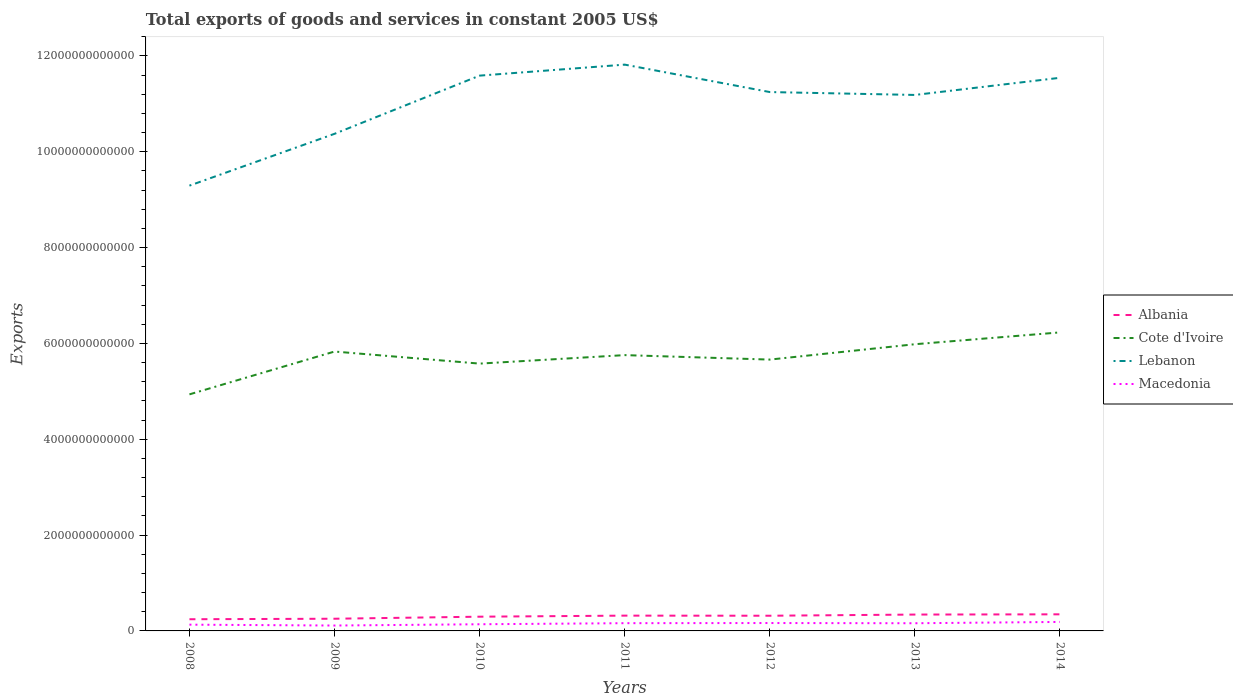Does the line corresponding to Cote d'Ivoire intersect with the line corresponding to Albania?
Offer a very short reply. No. Across all years, what is the maximum total exports of goods and services in Lebanon?
Make the answer very short. 9.29e+12. What is the total total exports of goods and services in Cote d'Ivoire in the graph?
Offer a terse response. 2.52e+11. What is the difference between the highest and the second highest total exports of goods and services in Cote d'Ivoire?
Offer a terse response. 1.29e+12. Is the total exports of goods and services in Albania strictly greater than the total exports of goods and services in Macedonia over the years?
Provide a short and direct response. No. What is the difference between two consecutive major ticks on the Y-axis?
Provide a succinct answer. 2.00e+12. Are the values on the major ticks of Y-axis written in scientific E-notation?
Offer a terse response. No. Does the graph contain any zero values?
Your answer should be compact. No. How many legend labels are there?
Offer a terse response. 4. What is the title of the graph?
Offer a terse response. Total exports of goods and services in constant 2005 US$. Does "Montenegro" appear as one of the legend labels in the graph?
Provide a short and direct response. No. What is the label or title of the X-axis?
Offer a very short reply. Years. What is the label or title of the Y-axis?
Provide a short and direct response. Exports. What is the Exports of Albania in 2008?
Your response must be concise. 2.44e+11. What is the Exports of Cote d'Ivoire in 2008?
Your response must be concise. 4.94e+12. What is the Exports of Lebanon in 2008?
Ensure brevity in your answer.  9.29e+12. What is the Exports of Macedonia in 2008?
Your answer should be very brief. 1.31e+11. What is the Exports in Albania in 2009?
Provide a succinct answer. 2.54e+11. What is the Exports of Cote d'Ivoire in 2009?
Your answer should be compact. 5.83e+12. What is the Exports in Lebanon in 2009?
Provide a short and direct response. 1.04e+13. What is the Exports of Macedonia in 2009?
Your answer should be compact. 1.12e+11. What is the Exports of Albania in 2010?
Make the answer very short. 2.97e+11. What is the Exports in Cote d'Ivoire in 2010?
Your answer should be compact. 5.58e+12. What is the Exports in Lebanon in 2010?
Offer a very short reply. 1.16e+13. What is the Exports in Macedonia in 2010?
Give a very brief answer. 1.39e+11. What is the Exports in Albania in 2011?
Keep it short and to the point. 3.19e+11. What is the Exports of Cote d'Ivoire in 2011?
Keep it short and to the point. 5.76e+12. What is the Exports in Lebanon in 2011?
Ensure brevity in your answer.  1.18e+13. What is the Exports in Macedonia in 2011?
Provide a short and direct response. 1.62e+11. What is the Exports of Albania in 2012?
Offer a terse response. 3.17e+11. What is the Exports of Cote d'Ivoire in 2012?
Your response must be concise. 5.66e+12. What is the Exports in Lebanon in 2012?
Provide a succinct answer. 1.12e+13. What is the Exports of Macedonia in 2012?
Provide a succinct answer. 1.65e+11. What is the Exports in Albania in 2013?
Provide a succinct answer. 3.41e+11. What is the Exports in Cote d'Ivoire in 2013?
Keep it short and to the point. 5.98e+12. What is the Exports of Lebanon in 2013?
Provide a short and direct response. 1.12e+13. What is the Exports in Macedonia in 2013?
Your answer should be very brief. 1.60e+11. What is the Exports in Albania in 2014?
Make the answer very short. 3.46e+11. What is the Exports in Cote d'Ivoire in 2014?
Your answer should be compact. 6.23e+12. What is the Exports of Lebanon in 2014?
Keep it short and to the point. 1.15e+13. What is the Exports of Macedonia in 2014?
Make the answer very short. 1.88e+11. Across all years, what is the maximum Exports in Albania?
Offer a very short reply. 3.46e+11. Across all years, what is the maximum Exports in Cote d'Ivoire?
Your answer should be very brief. 6.23e+12. Across all years, what is the maximum Exports in Lebanon?
Provide a succinct answer. 1.18e+13. Across all years, what is the maximum Exports in Macedonia?
Provide a short and direct response. 1.88e+11. Across all years, what is the minimum Exports in Albania?
Ensure brevity in your answer.  2.44e+11. Across all years, what is the minimum Exports in Cote d'Ivoire?
Your answer should be very brief. 4.94e+12. Across all years, what is the minimum Exports of Lebanon?
Your answer should be compact. 9.29e+12. Across all years, what is the minimum Exports of Macedonia?
Your response must be concise. 1.12e+11. What is the total Exports of Albania in the graph?
Make the answer very short. 2.12e+12. What is the total Exports of Cote d'Ivoire in the graph?
Provide a succinct answer. 4.00e+13. What is the total Exports in Lebanon in the graph?
Offer a terse response. 7.70e+13. What is the total Exports of Macedonia in the graph?
Ensure brevity in your answer.  1.06e+12. What is the difference between the Exports of Albania in 2008 and that in 2009?
Keep it short and to the point. -1.06e+1. What is the difference between the Exports of Cote d'Ivoire in 2008 and that in 2009?
Offer a terse response. -8.94e+11. What is the difference between the Exports of Lebanon in 2008 and that in 2009?
Your answer should be very brief. -1.08e+12. What is the difference between the Exports in Macedonia in 2008 and that in 2009?
Offer a terse response. 1.81e+1. What is the difference between the Exports of Albania in 2008 and that in 2010?
Your response must be concise. -5.33e+1. What is the difference between the Exports in Cote d'Ivoire in 2008 and that in 2010?
Offer a very short reply. -6.42e+11. What is the difference between the Exports in Lebanon in 2008 and that in 2010?
Offer a terse response. -2.30e+12. What is the difference between the Exports of Macedonia in 2008 and that in 2010?
Your response must be concise. -8.49e+09. What is the difference between the Exports in Albania in 2008 and that in 2011?
Offer a very short reply. -7.53e+1. What is the difference between the Exports of Cote d'Ivoire in 2008 and that in 2011?
Offer a very short reply. -8.19e+11. What is the difference between the Exports in Lebanon in 2008 and that in 2011?
Your answer should be very brief. -2.53e+12. What is the difference between the Exports of Macedonia in 2008 and that in 2011?
Ensure brevity in your answer.  -3.09e+1. What is the difference between the Exports of Albania in 2008 and that in 2012?
Provide a succinct answer. -7.32e+1. What is the difference between the Exports of Cote d'Ivoire in 2008 and that in 2012?
Keep it short and to the point. -7.26e+11. What is the difference between the Exports in Lebanon in 2008 and that in 2012?
Your answer should be compact. -1.95e+12. What is the difference between the Exports in Macedonia in 2008 and that in 2012?
Your response must be concise. -3.41e+1. What is the difference between the Exports in Albania in 2008 and that in 2013?
Your response must be concise. -9.76e+1. What is the difference between the Exports in Cote d'Ivoire in 2008 and that in 2013?
Offer a terse response. -1.05e+12. What is the difference between the Exports of Lebanon in 2008 and that in 2013?
Your answer should be very brief. -1.89e+12. What is the difference between the Exports in Macedonia in 2008 and that in 2013?
Give a very brief answer. -2.97e+1. What is the difference between the Exports of Albania in 2008 and that in 2014?
Provide a short and direct response. -1.03e+11. What is the difference between the Exports in Cote d'Ivoire in 2008 and that in 2014?
Offer a very short reply. -1.29e+12. What is the difference between the Exports of Lebanon in 2008 and that in 2014?
Your answer should be very brief. -2.25e+12. What is the difference between the Exports of Macedonia in 2008 and that in 2014?
Your answer should be very brief. -5.70e+1. What is the difference between the Exports in Albania in 2009 and that in 2010?
Offer a terse response. -4.27e+1. What is the difference between the Exports of Cote d'Ivoire in 2009 and that in 2010?
Your response must be concise. 2.52e+11. What is the difference between the Exports of Lebanon in 2009 and that in 2010?
Your answer should be compact. -1.21e+12. What is the difference between the Exports in Macedonia in 2009 and that in 2010?
Make the answer very short. -2.66e+1. What is the difference between the Exports of Albania in 2009 and that in 2011?
Your answer should be compact. -6.47e+1. What is the difference between the Exports in Cote d'Ivoire in 2009 and that in 2011?
Keep it short and to the point. 7.47e+1. What is the difference between the Exports of Lebanon in 2009 and that in 2011?
Your answer should be very brief. -1.44e+12. What is the difference between the Exports of Macedonia in 2009 and that in 2011?
Offer a terse response. -4.91e+1. What is the difference between the Exports of Albania in 2009 and that in 2012?
Give a very brief answer. -6.26e+1. What is the difference between the Exports in Cote d'Ivoire in 2009 and that in 2012?
Your answer should be very brief. 1.68e+11. What is the difference between the Exports in Lebanon in 2009 and that in 2012?
Keep it short and to the point. -8.71e+11. What is the difference between the Exports in Macedonia in 2009 and that in 2012?
Provide a short and direct response. -5.22e+1. What is the difference between the Exports in Albania in 2009 and that in 2013?
Make the answer very short. -8.70e+1. What is the difference between the Exports in Cote d'Ivoire in 2009 and that in 2013?
Give a very brief answer. -1.53e+11. What is the difference between the Exports of Lebanon in 2009 and that in 2013?
Offer a very short reply. -8.11e+11. What is the difference between the Exports in Macedonia in 2009 and that in 2013?
Your response must be concise. -4.78e+1. What is the difference between the Exports of Albania in 2009 and that in 2014?
Provide a short and direct response. -9.19e+1. What is the difference between the Exports in Cote d'Ivoire in 2009 and that in 2014?
Make the answer very short. -3.99e+11. What is the difference between the Exports in Lebanon in 2009 and that in 2014?
Your response must be concise. -1.17e+12. What is the difference between the Exports of Macedonia in 2009 and that in 2014?
Your answer should be compact. -7.51e+1. What is the difference between the Exports of Albania in 2010 and that in 2011?
Provide a short and direct response. -2.20e+1. What is the difference between the Exports of Cote d'Ivoire in 2010 and that in 2011?
Ensure brevity in your answer.  -1.77e+11. What is the difference between the Exports of Lebanon in 2010 and that in 2011?
Your answer should be compact. -2.30e+11. What is the difference between the Exports of Macedonia in 2010 and that in 2011?
Make the answer very short. -2.24e+1. What is the difference between the Exports in Albania in 2010 and that in 2012?
Ensure brevity in your answer.  -2.00e+1. What is the difference between the Exports in Cote d'Ivoire in 2010 and that in 2012?
Your answer should be compact. -8.40e+1. What is the difference between the Exports in Lebanon in 2010 and that in 2012?
Your answer should be very brief. 3.43e+11. What is the difference between the Exports in Macedonia in 2010 and that in 2012?
Your answer should be compact. -2.56e+1. What is the difference between the Exports of Albania in 2010 and that in 2013?
Your answer should be very brief. -4.44e+1. What is the difference between the Exports of Cote d'Ivoire in 2010 and that in 2013?
Provide a short and direct response. -4.04e+11. What is the difference between the Exports in Lebanon in 2010 and that in 2013?
Provide a short and direct response. 4.03e+11. What is the difference between the Exports in Macedonia in 2010 and that in 2013?
Keep it short and to the point. -2.12e+1. What is the difference between the Exports of Albania in 2010 and that in 2014?
Provide a succinct answer. -4.92e+1. What is the difference between the Exports in Cote d'Ivoire in 2010 and that in 2014?
Make the answer very short. -6.51e+11. What is the difference between the Exports of Lebanon in 2010 and that in 2014?
Provide a succinct answer. 4.51e+1. What is the difference between the Exports of Macedonia in 2010 and that in 2014?
Your answer should be very brief. -4.85e+1. What is the difference between the Exports in Albania in 2011 and that in 2012?
Offer a terse response. 2.04e+09. What is the difference between the Exports of Cote d'Ivoire in 2011 and that in 2012?
Your response must be concise. 9.32e+1. What is the difference between the Exports of Lebanon in 2011 and that in 2012?
Give a very brief answer. 5.72e+11. What is the difference between the Exports of Macedonia in 2011 and that in 2012?
Offer a very short reply. -3.15e+09. What is the difference between the Exports in Albania in 2011 and that in 2013?
Offer a terse response. -2.24e+1. What is the difference between the Exports in Cote d'Ivoire in 2011 and that in 2013?
Make the answer very short. -2.27e+11. What is the difference between the Exports of Lebanon in 2011 and that in 2013?
Offer a terse response. 6.33e+11. What is the difference between the Exports of Macedonia in 2011 and that in 2013?
Your response must be concise. 1.27e+09. What is the difference between the Exports of Albania in 2011 and that in 2014?
Keep it short and to the point. -2.72e+1. What is the difference between the Exports of Cote d'Ivoire in 2011 and that in 2014?
Keep it short and to the point. -4.74e+11. What is the difference between the Exports in Lebanon in 2011 and that in 2014?
Give a very brief answer. 2.75e+11. What is the difference between the Exports of Macedonia in 2011 and that in 2014?
Give a very brief answer. -2.60e+1. What is the difference between the Exports in Albania in 2012 and that in 2013?
Your response must be concise. -2.44e+1. What is the difference between the Exports of Cote d'Ivoire in 2012 and that in 2013?
Make the answer very short. -3.20e+11. What is the difference between the Exports of Lebanon in 2012 and that in 2013?
Make the answer very short. 6.03e+1. What is the difference between the Exports of Macedonia in 2012 and that in 2013?
Provide a short and direct response. 4.42e+09. What is the difference between the Exports of Albania in 2012 and that in 2014?
Offer a terse response. -2.93e+1. What is the difference between the Exports in Cote d'Ivoire in 2012 and that in 2014?
Your response must be concise. -5.67e+11. What is the difference between the Exports in Lebanon in 2012 and that in 2014?
Keep it short and to the point. -2.98e+11. What is the difference between the Exports of Macedonia in 2012 and that in 2014?
Provide a succinct answer. -2.29e+1. What is the difference between the Exports in Albania in 2013 and that in 2014?
Your answer should be very brief. -4.86e+09. What is the difference between the Exports of Cote d'Ivoire in 2013 and that in 2014?
Provide a succinct answer. -2.47e+11. What is the difference between the Exports of Lebanon in 2013 and that in 2014?
Provide a succinct answer. -3.58e+11. What is the difference between the Exports of Macedonia in 2013 and that in 2014?
Your response must be concise. -2.73e+1. What is the difference between the Exports in Albania in 2008 and the Exports in Cote d'Ivoire in 2009?
Provide a short and direct response. -5.59e+12. What is the difference between the Exports of Albania in 2008 and the Exports of Lebanon in 2009?
Provide a succinct answer. -1.01e+13. What is the difference between the Exports of Albania in 2008 and the Exports of Macedonia in 2009?
Provide a succinct answer. 1.31e+11. What is the difference between the Exports in Cote d'Ivoire in 2008 and the Exports in Lebanon in 2009?
Keep it short and to the point. -5.44e+12. What is the difference between the Exports of Cote d'Ivoire in 2008 and the Exports of Macedonia in 2009?
Your answer should be very brief. 4.82e+12. What is the difference between the Exports of Lebanon in 2008 and the Exports of Macedonia in 2009?
Make the answer very short. 9.18e+12. What is the difference between the Exports of Albania in 2008 and the Exports of Cote d'Ivoire in 2010?
Offer a very short reply. -5.33e+12. What is the difference between the Exports of Albania in 2008 and the Exports of Lebanon in 2010?
Give a very brief answer. -1.13e+13. What is the difference between the Exports in Albania in 2008 and the Exports in Macedonia in 2010?
Offer a terse response. 1.05e+11. What is the difference between the Exports in Cote d'Ivoire in 2008 and the Exports in Lebanon in 2010?
Offer a very short reply. -6.65e+12. What is the difference between the Exports in Cote d'Ivoire in 2008 and the Exports in Macedonia in 2010?
Keep it short and to the point. 4.80e+12. What is the difference between the Exports in Lebanon in 2008 and the Exports in Macedonia in 2010?
Ensure brevity in your answer.  9.15e+12. What is the difference between the Exports of Albania in 2008 and the Exports of Cote d'Ivoire in 2011?
Provide a short and direct response. -5.51e+12. What is the difference between the Exports in Albania in 2008 and the Exports in Lebanon in 2011?
Your answer should be compact. -1.16e+13. What is the difference between the Exports of Albania in 2008 and the Exports of Macedonia in 2011?
Provide a short and direct response. 8.23e+1. What is the difference between the Exports in Cote d'Ivoire in 2008 and the Exports in Lebanon in 2011?
Make the answer very short. -6.88e+12. What is the difference between the Exports in Cote d'Ivoire in 2008 and the Exports in Macedonia in 2011?
Keep it short and to the point. 4.77e+12. What is the difference between the Exports in Lebanon in 2008 and the Exports in Macedonia in 2011?
Make the answer very short. 9.13e+12. What is the difference between the Exports of Albania in 2008 and the Exports of Cote d'Ivoire in 2012?
Your answer should be compact. -5.42e+12. What is the difference between the Exports in Albania in 2008 and the Exports in Lebanon in 2012?
Provide a short and direct response. -1.10e+13. What is the difference between the Exports of Albania in 2008 and the Exports of Macedonia in 2012?
Your answer should be compact. 7.91e+1. What is the difference between the Exports in Cote d'Ivoire in 2008 and the Exports in Lebanon in 2012?
Offer a very short reply. -6.31e+12. What is the difference between the Exports in Cote d'Ivoire in 2008 and the Exports in Macedonia in 2012?
Make the answer very short. 4.77e+12. What is the difference between the Exports in Lebanon in 2008 and the Exports in Macedonia in 2012?
Offer a terse response. 9.13e+12. What is the difference between the Exports of Albania in 2008 and the Exports of Cote d'Ivoire in 2013?
Your answer should be very brief. -5.74e+12. What is the difference between the Exports of Albania in 2008 and the Exports of Lebanon in 2013?
Your answer should be compact. -1.09e+13. What is the difference between the Exports of Albania in 2008 and the Exports of Macedonia in 2013?
Offer a very short reply. 8.35e+1. What is the difference between the Exports of Cote d'Ivoire in 2008 and the Exports of Lebanon in 2013?
Ensure brevity in your answer.  -6.25e+12. What is the difference between the Exports of Cote d'Ivoire in 2008 and the Exports of Macedonia in 2013?
Offer a very short reply. 4.78e+12. What is the difference between the Exports in Lebanon in 2008 and the Exports in Macedonia in 2013?
Give a very brief answer. 9.13e+12. What is the difference between the Exports in Albania in 2008 and the Exports in Cote d'Ivoire in 2014?
Offer a terse response. -5.99e+12. What is the difference between the Exports of Albania in 2008 and the Exports of Lebanon in 2014?
Your answer should be very brief. -1.13e+13. What is the difference between the Exports in Albania in 2008 and the Exports in Macedonia in 2014?
Your answer should be compact. 5.62e+1. What is the difference between the Exports of Cote d'Ivoire in 2008 and the Exports of Lebanon in 2014?
Give a very brief answer. -6.61e+12. What is the difference between the Exports in Cote d'Ivoire in 2008 and the Exports in Macedonia in 2014?
Your answer should be very brief. 4.75e+12. What is the difference between the Exports in Lebanon in 2008 and the Exports in Macedonia in 2014?
Ensure brevity in your answer.  9.10e+12. What is the difference between the Exports in Albania in 2009 and the Exports in Cote d'Ivoire in 2010?
Your answer should be compact. -5.32e+12. What is the difference between the Exports in Albania in 2009 and the Exports in Lebanon in 2010?
Give a very brief answer. -1.13e+13. What is the difference between the Exports of Albania in 2009 and the Exports of Macedonia in 2010?
Keep it short and to the point. 1.15e+11. What is the difference between the Exports in Cote d'Ivoire in 2009 and the Exports in Lebanon in 2010?
Keep it short and to the point. -5.76e+12. What is the difference between the Exports of Cote d'Ivoire in 2009 and the Exports of Macedonia in 2010?
Offer a very short reply. 5.69e+12. What is the difference between the Exports in Lebanon in 2009 and the Exports in Macedonia in 2010?
Provide a succinct answer. 1.02e+13. What is the difference between the Exports of Albania in 2009 and the Exports of Cote d'Ivoire in 2011?
Make the answer very short. -5.50e+12. What is the difference between the Exports of Albania in 2009 and the Exports of Lebanon in 2011?
Your answer should be compact. -1.16e+13. What is the difference between the Exports of Albania in 2009 and the Exports of Macedonia in 2011?
Offer a very short reply. 9.29e+1. What is the difference between the Exports in Cote d'Ivoire in 2009 and the Exports in Lebanon in 2011?
Your response must be concise. -5.99e+12. What is the difference between the Exports of Cote d'Ivoire in 2009 and the Exports of Macedonia in 2011?
Keep it short and to the point. 5.67e+12. What is the difference between the Exports in Lebanon in 2009 and the Exports in Macedonia in 2011?
Offer a terse response. 1.02e+13. What is the difference between the Exports in Albania in 2009 and the Exports in Cote d'Ivoire in 2012?
Give a very brief answer. -5.41e+12. What is the difference between the Exports of Albania in 2009 and the Exports of Lebanon in 2012?
Give a very brief answer. -1.10e+13. What is the difference between the Exports of Albania in 2009 and the Exports of Macedonia in 2012?
Provide a succinct answer. 8.97e+1. What is the difference between the Exports of Cote d'Ivoire in 2009 and the Exports of Lebanon in 2012?
Ensure brevity in your answer.  -5.41e+12. What is the difference between the Exports of Cote d'Ivoire in 2009 and the Exports of Macedonia in 2012?
Your response must be concise. 5.67e+12. What is the difference between the Exports of Lebanon in 2009 and the Exports of Macedonia in 2012?
Give a very brief answer. 1.02e+13. What is the difference between the Exports in Albania in 2009 and the Exports in Cote d'Ivoire in 2013?
Your answer should be very brief. -5.73e+12. What is the difference between the Exports of Albania in 2009 and the Exports of Lebanon in 2013?
Ensure brevity in your answer.  -1.09e+13. What is the difference between the Exports of Albania in 2009 and the Exports of Macedonia in 2013?
Make the answer very short. 9.41e+1. What is the difference between the Exports in Cote d'Ivoire in 2009 and the Exports in Lebanon in 2013?
Your answer should be very brief. -5.35e+12. What is the difference between the Exports of Cote d'Ivoire in 2009 and the Exports of Macedonia in 2013?
Your response must be concise. 5.67e+12. What is the difference between the Exports of Lebanon in 2009 and the Exports of Macedonia in 2013?
Keep it short and to the point. 1.02e+13. What is the difference between the Exports in Albania in 2009 and the Exports in Cote d'Ivoire in 2014?
Give a very brief answer. -5.97e+12. What is the difference between the Exports in Albania in 2009 and the Exports in Lebanon in 2014?
Ensure brevity in your answer.  -1.13e+13. What is the difference between the Exports of Albania in 2009 and the Exports of Macedonia in 2014?
Give a very brief answer. 6.68e+1. What is the difference between the Exports of Cote d'Ivoire in 2009 and the Exports of Lebanon in 2014?
Make the answer very short. -5.71e+12. What is the difference between the Exports in Cote d'Ivoire in 2009 and the Exports in Macedonia in 2014?
Ensure brevity in your answer.  5.64e+12. What is the difference between the Exports in Lebanon in 2009 and the Exports in Macedonia in 2014?
Offer a terse response. 1.02e+13. What is the difference between the Exports in Albania in 2010 and the Exports in Cote d'Ivoire in 2011?
Your answer should be compact. -5.46e+12. What is the difference between the Exports in Albania in 2010 and the Exports in Lebanon in 2011?
Provide a short and direct response. -1.15e+13. What is the difference between the Exports of Albania in 2010 and the Exports of Macedonia in 2011?
Your answer should be very brief. 1.36e+11. What is the difference between the Exports of Cote d'Ivoire in 2010 and the Exports of Lebanon in 2011?
Offer a terse response. -6.24e+12. What is the difference between the Exports in Cote d'Ivoire in 2010 and the Exports in Macedonia in 2011?
Keep it short and to the point. 5.42e+12. What is the difference between the Exports in Lebanon in 2010 and the Exports in Macedonia in 2011?
Keep it short and to the point. 1.14e+13. What is the difference between the Exports of Albania in 2010 and the Exports of Cote d'Ivoire in 2012?
Keep it short and to the point. -5.36e+12. What is the difference between the Exports of Albania in 2010 and the Exports of Lebanon in 2012?
Provide a succinct answer. -1.09e+13. What is the difference between the Exports in Albania in 2010 and the Exports in Macedonia in 2012?
Offer a very short reply. 1.32e+11. What is the difference between the Exports in Cote d'Ivoire in 2010 and the Exports in Lebanon in 2012?
Keep it short and to the point. -5.67e+12. What is the difference between the Exports in Cote d'Ivoire in 2010 and the Exports in Macedonia in 2012?
Provide a short and direct response. 5.41e+12. What is the difference between the Exports in Lebanon in 2010 and the Exports in Macedonia in 2012?
Make the answer very short. 1.14e+13. What is the difference between the Exports in Albania in 2010 and the Exports in Cote d'Ivoire in 2013?
Make the answer very short. -5.69e+12. What is the difference between the Exports in Albania in 2010 and the Exports in Lebanon in 2013?
Keep it short and to the point. -1.09e+13. What is the difference between the Exports in Albania in 2010 and the Exports in Macedonia in 2013?
Your answer should be very brief. 1.37e+11. What is the difference between the Exports in Cote d'Ivoire in 2010 and the Exports in Lebanon in 2013?
Give a very brief answer. -5.61e+12. What is the difference between the Exports of Cote d'Ivoire in 2010 and the Exports of Macedonia in 2013?
Your response must be concise. 5.42e+12. What is the difference between the Exports in Lebanon in 2010 and the Exports in Macedonia in 2013?
Provide a short and direct response. 1.14e+13. What is the difference between the Exports in Albania in 2010 and the Exports in Cote d'Ivoire in 2014?
Provide a short and direct response. -5.93e+12. What is the difference between the Exports in Albania in 2010 and the Exports in Lebanon in 2014?
Ensure brevity in your answer.  -1.12e+13. What is the difference between the Exports of Albania in 2010 and the Exports of Macedonia in 2014?
Provide a short and direct response. 1.09e+11. What is the difference between the Exports of Cote d'Ivoire in 2010 and the Exports of Lebanon in 2014?
Ensure brevity in your answer.  -5.96e+12. What is the difference between the Exports in Cote d'Ivoire in 2010 and the Exports in Macedonia in 2014?
Offer a very short reply. 5.39e+12. What is the difference between the Exports in Lebanon in 2010 and the Exports in Macedonia in 2014?
Your answer should be very brief. 1.14e+13. What is the difference between the Exports of Albania in 2011 and the Exports of Cote d'Ivoire in 2012?
Give a very brief answer. -5.34e+12. What is the difference between the Exports of Albania in 2011 and the Exports of Lebanon in 2012?
Keep it short and to the point. -1.09e+13. What is the difference between the Exports in Albania in 2011 and the Exports in Macedonia in 2012?
Offer a terse response. 1.54e+11. What is the difference between the Exports in Cote d'Ivoire in 2011 and the Exports in Lebanon in 2012?
Offer a terse response. -5.49e+12. What is the difference between the Exports in Cote d'Ivoire in 2011 and the Exports in Macedonia in 2012?
Your response must be concise. 5.59e+12. What is the difference between the Exports in Lebanon in 2011 and the Exports in Macedonia in 2012?
Offer a terse response. 1.17e+13. What is the difference between the Exports of Albania in 2011 and the Exports of Cote d'Ivoire in 2013?
Your answer should be very brief. -5.66e+12. What is the difference between the Exports of Albania in 2011 and the Exports of Lebanon in 2013?
Keep it short and to the point. -1.09e+13. What is the difference between the Exports of Albania in 2011 and the Exports of Macedonia in 2013?
Offer a terse response. 1.59e+11. What is the difference between the Exports in Cote d'Ivoire in 2011 and the Exports in Lebanon in 2013?
Offer a terse response. -5.43e+12. What is the difference between the Exports of Cote d'Ivoire in 2011 and the Exports of Macedonia in 2013?
Provide a short and direct response. 5.59e+12. What is the difference between the Exports of Lebanon in 2011 and the Exports of Macedonia in 2013?
Give a very brief answer. 1.17e+13. What is the difference between the Exports of Albania in 2011 and the Exports of Cote d'Ivoire in 2014?
Make the answer very short. -5.91e+12. What is the difference between the Exports of Albania in 2011 and the Exports of Lebanon in 2014?
Give a very brief answer. -1.12e+13. What is the difference between the Exports in Albania in 2011 and the Exports in Macedonia in 2014?
Provide a succinct answer. 1.31e+11. What is the difference between the Exports in Cote d'Ivoire in 2011 and the Exports in Lebanon in 2014?
Offer a terse response. -5.79e+12. What is the difference between the Exports in Cote d'Ivoire in 2011 and the Exports in Macedonia in 2014?
Keep it short and to the point. 5.57e+12. What is the difference between the Exports of Lebanon in 2011 and the Exports of Macedonia in 2014?
Keep it short and to the point. 1.16e+13. What is the difference between the Exports in Albania in 2012 and the Exports in Cote d'Ivoire in 2013?
Your response must be concise. -5.67e+12. What is the difference between the Exports of Albania in 2012 and the Exports of Lebanon in 2013?
Provide a short and direct response. -1.09e+13. What is the difference between the Exports of Albania in 2012 and the Exports of Macedonia in 2013?
Your answer should be compact. 1.57e+11. What is the difference between the Exports of Cote d'Ivoire in 2012 and the Exports of Lebanon in 2013?
Give a very brief answer. -5.52e+12. What is the difference between the Exports in Cote d'Ivoire in 2012 and the Exports in Macedonia in 2013?
Give a very brief answer. 5.50e+12. What is the difference between the Exports of Lebanon in 2012 and the Exports of Macedonia in 2013?
Ensure brevity in your answer.  1.11e+13. What is the difference between the Exports of Albania in 2012 and the Exports of Cote d'Ivoire in 2014?
Keep it short and to the point. -5.91e+12. What is the difference between the Exports of Albania in 2012 and the Exports of Lebanon in 2014?
Your answer should be very brief. -1.12e+13. What is the difference between the Exports in Albania in 2012 and the Exports in Macedonia in 2014?
Offer a terse response. 1.29e+11. What is the difference between the Exports in Cote d'Ivoire in 2012 and the Exports in Lebanon in 2014?
Make the answer very short. -5.88e+12. What is the difference between the Exports in Cote d'Ivoire in 2012 and the Exports in Macedonia in 2014?
Your response must be concise. 5.47e+12. What is the difference between the Exports of Lebanon in 2012 and the Exports of Macedonia in 2014?
Your answer should be compact. 1.11e+13. What is the difference between the Exports in Albania in 2013 and the Exports in Cote d'Ivoire in 2014?
Provide a succinct answer. -5.89e+12. What is the difference between the Exports of Albania in 2013 and the Exports of Lebanon in 2014?
Your response must be concise. -1.12e+13. What is the difference between the Exports of Albania in 2013 and the Exports of Macedonia in 2014?
Offer a very short reply. 1.54e+11. What is the difference between the Exports of Cote d'Ivoire in 2013 and the Exports of Lebanon in 2014?
Provide a short and direct response. -5.56e+12. What is the difference between the Exports in Cote d'Ivoire in 2013 and the Exports in Macedonia in 2014?
Your response must be concise. 5.79e+12. What is the difference between the Exports of Lebanon in 2013 and the Exports of Macedonia in 2014?
Offer a very short reply. 1.10e+13. What is the average Exports of Albania per year?
Ensure brevity in your answer.  3.03e+11. What is the average Exports of Cote d'Ivoire per year?
Make the answer very short. 5.71e+12. What is the average Exports of Lebanon per year?
Ensure brevity in your answer.  1.10e+13. What is the average Exports of Macedonia per year?
Provide a short and direct response. 1.51e+11. In the year 2008, what is the difference between the Exports in Albania and Exports in Cote d'Ivoire?
Offer a very short reply. -4.69e+12. In the year 2008, what is the difference between the Exports of Albania and Exports of Lebanon?
Provide a succinct answer. -9.05e+12. In the year 2008, what is the difference between the Exports of Albania and Exports of Macedonia?
Give a very brief answer. 1.13e+11. In the year 2008, what is the difference between the Exports in Cote d'Ivoire and Exports in Lebanon?
Offer a very short reply. -4.36e+12. In the year 2008, what is the difference between the Exports in Cote d'Ivoire and Exports in Macedonia?
Provide a succinct answer. 4.81e+12. In the year 2008, what is the difference between the Exports in Lebanon and Exports in Macedonia?
Your response must be concise. 9.16e+12. In the year 2009, what is the difference between the Exports in Albania and Exports in Cote d'Ivoire?
Your answer should be very brief. -5.58e+12. In the year 2009, what is the difference between the Exports in Albania and Exports in Lebanon?
Your answer should be compact. -1.01e+13. In the year 2009, what is the difference between the Exports of Albania and Exports of Macedonia?
Provide a short and direct response. 1.42e+11. In the year 2009, what is the difference between the Exports in Cote d'Ivoire and Exports in Lebanon?
Give a very brief answer. -4.54e+12. In the year 2009, what is the difference between the Exports in Cote d'Ivoire and Exports in Macedonia?
Keep it short and to the point. 5.72e+12. In the year 2009, what is the difference between the Exports in Lebanon and Exports in Macedonia?
Ensure brevity in your answer.  1.03e+13. In the year 2010, what is the difference between the Exports in Albania and Exports in Cote d'Ivoire?
Offer a terse response. -5.28e+12. In the year 2010, what is the difference between the Exports in Albania and Exports in Lebanon?
Provide a short and direct response. -1.13e+13. In the year 2010, what is the difference between the Exports in Albania and Exports in Macedonia?
Give a very brief answer. 1.58e+11. In the year 2010, what is the difference between the Exports of Cote d'Ivoire and Exports of Lebanon?
Provide a succinct answer. -6.01e+12. In the year 2010, what is the difference between the Exports in Cote d'Ivoire and Exports in Macedonia?
Keep it short and to the point. 5.44e+12. In the year 2010, what is the difference between the Exports in Lebanon and Exports in Macedonia?
Ensure brevity in your answer.  1.14e+13. In the year 2011, what is the difference between the Exports of Albania and Exports of Cote d'Ivoire?
Your response must be concise. -5.44e+12. In the year 2011, what is the difference between the Exports in Albania and Exports in Lebanon?
Keep it short and to the point. -1.15e+13. In the year 2011, what is the difference between the Exports of Albania and Exports of Macedonia?
Provide a succinct answer. 1.58e+11. In the year 2011, what is the difference between the Exports in Cote d'Ivoire and Exports in Lebanon?
Provide a succinct answer. -6.06e+12. In the year 2011, what is the difference between the Exports of Cote d'Ivoire and Exports of Macedonia?
Offer a very short reply. 5.59e+12. In the year 2011, what is the difference between the Exports in Lebanon and Exports in Macedonia?
Keep it short and to the point. 1.17e+13. In the year 2012, what is the difference between the Exports in Albania and Exports in Cote d'Ivoire?
Provide a short and direct response. -5.34e+12. In the year 2012, what is the difference between the Exports of Albania and Exports of Lebanon?
Give a very brief answer. -1.09e+13. In the year 2012, what is the difference between the Exports in Albania and Exports in Macedonia?
Provide a short and direct response. 1.52e+11. In the year 2012, what is the difference between the Exports in Cote d'Ivoire and Exports in Lebanon?
Keep it short and to the point. -5.58e+12. In the year 2012, what is the difference between the Exports in Cote d'Ivoire and Exports in Macedonia?
Ensure brevity in your answer.  5.50e+12. In the year 2012, what is the difference between the Exports in Lebanon and Exports in Macedonia?
Offer a terse response. 1.11e+13. In the year 2013, what is the difference between the Exports in Albania and Exports in Cote d'Ivoire?
Make the answer very short. -5.64e+12. In the year 2013, what is the difference between the Exports of Albania and Exports of Lebanon?
Offer a terse response. -1.08e+13. In the year 2013, what is the difference between the Exports of Albania and Exports of Macedonia?
Provide a succinct answer. 1.81e+11. In the year 2013, what is the difference between the Exports of Cote d'Ivoire and Exports of Lebanon?
Give a very brief answer. -5.20e+12. In the year 2013, what is the difference between the Exports of Cote d'Ivoire and Exports of Macedonia?
Provide a succinct answer. 5.82e+12. In the year 2013, what is the difference between the Exports of Lebanon and Exports of Macedonia?
Your response must be concise. 1.10e+13. In the year 2014, what is the difference between the Exports in Albania and Exports in Cote d'Ivoire?
Your answer should be compact. -5.88e+12. In the year 2014, what is the difference between the Exports in Albania and Exports in Lebanon?
Your response must be concise. -1.12e+13. In the year 2014, what is the difference between the Exports of Albania and Exports of Macedonia?
Provide a short and direct response. 1.59e+11. In the year 2014, what is the difference between the Exports in Cote d'Ivoire and Exports in Lebanon?
Offer a very short reply. -5.31e+12. In the year 2014, what is the difference between the Exports of Cote d'Ivoire and Exports of Macedonia?
Ensure brevity in your answer.  6.04e+12. In the year 2014, what is the difference between the Exports in Lebanon and Exports in Macedonia?
Give a very brief answer. 1.14e+13. What is the ratio of the Exports of Albania in 2008 to that in 2009?
Provide a short and direct response. 0.96. What is the ratio of the Exports of Cote d'Ivoire in 2008 to that in 2009?
Ensure brevity in your answer.  0.85. What is the ratio of the Exports of Lebanon in 2008 to that in 2009?
Your answer should be compact. 0.9. What is the ratio of the Exports in Macedonia in 2008 to that in 2009?
Offer a very short reply. 1.16. What is the ratio of the Exports of Albania in 2008 to that in 2010?
Ensure brevity in your answer.  0.82. What is the ratio of the Exports in Cote d'Ivoire in 2008 to that in 2010?
Provide a short and direct response. 0.89. What is the ratio of the Exports of Lebanon in 2008 to that in 2010?
Your answer should be compact. 0.8. What is the ratio of the Exports of Macedonia in 2008 to that in 2010?
Give a very brief answer. 0.94. What is the ratio of the Exports of Albania in 2008 to that in 2011?
Your answer should be very brief. 0.76. What is the ratio of the Exports in Cote d'Ivoire in 2008 to that in 2011?
Offer a very short reply. 0.86. What is the ratio of the Exports in Lebanon in 2008 to that in 2011?
Your answer should be compact. 0.79. What is the ratio of the Exports in Macedonia in 2008 to that in 2011?
Ensure brevity in your answer.  0.81. What is the ratio of the Exports of Albania in 2008 to that in 2012?
Provide a short and direct response. 0.77. What is the ratio of the Exports in Cote d'Ivoire in 2008 to that in 2012?
Provide a short and direct response. 0.87. What is the ratio of the Exports in Lebanon in 2008 to that in 2012?
Offer a terse response. 0.83. What is the ratio of the Exports of Macedonia in 2008 to that in 2012?
Ensure brevity in your answer.  0.79. What is the ratio of the Exports of Albania in 2008 to that in 2013?
Ensure brevity in your answer.  0.71. What is the ratio of the Exports of Cote d'Ivoire in 2008 to that in 2013?
Provide a short and direct response. 0.83. What is the ratio of the Exports of Lebanon in 2008 to that in 2013?
Your response must be concise. 0.83. What is the ratio of the Exports in Macedonia in 2008 to that in 2013?
Offer a terse response. 0.81. What is the ratio of the Exports of Albania in 2008 to that in 2014?
Your answer should be very brief. 0.7. What is the ratio of the Exports in Cote d'Ivoire in 2008 to that in 2014?
Ensure brevity in your answer.  0.79. What is the ratio of the Exports in Lebanon in 2008 to that in 2014?
Provide a succinct answer. 0.81. What is the ratio of the Exports of Macedonia in 2008 to that in 2014?
Ensure brevity in your answer.  0.7. What is the ratio of the Exports in Albania in 2009 to that in 2010?
Ensure brevity in your answer.  0.86. What is the ratio of the Exports of Cote d'Ivoire in 2009 to that in 2010?
Provide a succinct answer. 1.05. What is the ratio of the Exports of Lebanon in 2009 to that in 2010?
Ensure brevity in your answer.  0.9. What is the ratio of the Exports in Macedonia in 2009 to that in 2010?
Offer a very short reply. 0.81. What is the ratio of the Exports of Albania in 2009 to that in 2011?
Ensure brevity in your answer.  0.8. What is the ratio of the Exports in Lebanon in 2009 to that in 2011?
Ensure brevity in your answer.  0.88. What is the ratio of the Exports of Macedonia in 2009 to that in 2011?
Provide a succinct answer. 0.7. What is the ratio of the Exports in Albania in 2009 to that in 2012?
Your answer should be very brief. 0.8. What is the ratio of the Exports in Cote d'Ivoire in 2009 to that in 2012?
Your response must be concise. 1.03. What is the ratio of the Exports of Lebanon in 2009 to that in 2012?
Provide a short and direct response. 0.92. What is the ratio of the Exports of Macedonia in 2009 to that in 2012?
Your answer should be compact. 0.68. What is the ratio of the Exports in Albania in 2009 to that in 2013?
Your response must be concise. 0.75. What is the ratio of the Exports in Cote d'Ivoire in 2009 to that in 2013?
Give a very brief answer. 0.97. What is the ratio of the Exports of Lebanon in 2009 to that in 2013?
Provide a short and direct response. 0.93. What is the ratio of the Exports of Macedonia in 2009 to that in 2013?
Ensure brevity in your answer.  0.7. What is the ratio of the Exports in Albania in 2009 to that in 2014?
Provide a short and direct response. 0.73. What is the ratio of the Exports in Cote d'Ivoire in 2009 to that in 2014?
Offer a terse response. 0.94. What is the ratio of the Exports of Lebanon in 2009 to that in 2014?
Provide a short and direct response. 0.9. What is the ratio of the Exports of Macedonia in 2009 to that in 2014?
Keep it short and to the point. 0.6. What is the ratio of the Exports in Albania in 2010 to that in 2011?
Ensure brevity in your answer.  0.93. What is the ratio of the Exports in Cote d'Ivoire in 2010 to that in 2011?
Make the answer very short. 0.97. What is the ratio of the Exports of Lebanon in 2010 to that in 2011?
Ensure brevity in your answer.  0.98. What is the ratio of the Exports in Macedonia in 2010 to that in 2011?
Ensure brevity in your answer.  0.86. What is the ratio of the Exports in Albania in 2010 to that in 2012?
Ensure brevity in your answer.  0.94. What is the ratio of the Exports in Cote d'Ivoire in 2010 to that in 2012?
Your answer should be very brief. 0.99. What is the ratio of the Exports in Lebanon in 2010 to that in 2012?
Give a very brief answer. 1.03. What is the ratio of the Exports in Macedonia in 2010 to that in 2012?
Your answer should be compact. 0.84. What is the ratio of the Exports in Albania in 2010 to that in 2013?
Offer a very short reply. 0.87. What is the ratio of the Exports of Cote d'Ivoire in 2010 to that in 2013?
Make the answer very short. 0.93. What is the ratio of the Exports in Lebanon in 2010 to that in 2013?
Ensure brevity in your answer.  1.04. What is the ratio of the Exports of Macedonia in 2010 to that in 2013?
Offer a very short reply. 0.87. What is the ratio of the Exports in Albania in 2010 to that in 2014?
Keep it short and to the point. 0.86. What is the ratio of the Exports in Cote d'Ivoire in 2010 to that in 2014?
Keep it short and to the point. 0.9. What is the ratio of the Exports in Macedonia in 2010 to that in 2014?
Provide a short and direct response. 0.74. What is the ratio of the Exports in Albania in 2011 to that in 2012?
Provide a short and direct response. 1.01. What is the ratio of the Exports of Cote d'Ivoire in 2011 to that in 2012?
Your response must be concise. 1.02. What is the ratio of the Exports in Lebanon in 2011 to that in 2012?
Make the answer very short. 1.05. What is the ratio of the Exports in Macedonia in 2011 to that in 2012?
Your response must be concise. 0.98. What is the ratio of the Exports in Albania in 2011 to that in 2013?
Make the answer very short. 0.93. What is the ratio of the Exports in Cote d'Ivoire in 2011 to that in 2013?
Ensure brevity in your answer.  0.96. What is the ratio of the Exports in Lebanon in 2011 to that in 2013?
Offer a terse response. 1.06. What is the ratio of the Exports in Macedonia in 2011 to that in 2013?
Offer a terse response. 1.01. What is the ratio of the Exports of Albania in 2011 to that in 2014?
Your answer should be compact. 0.92. What is the ratio of the Exports in Cote d'Ivoire in 2011 to that in 2014?
Give a very brief answer. 0.92. What is the ratio of the Exports of Lebanon in 2011 to that in 2014?
Offer a very short reply. 1.02. What is the ratio of the Exports of Macedonia in 2011 to that in 2014?
Provide a short and direct response. 0.86. What is the ratio of the Exports of Albania in 2012 to that in 2013?
Your answer should be compact. 0.93. What is the ratio of the Exports of Cote d'Ivoire in 2012 to that in 2013?
Keep it short and to the point. 0.95. What is the ratio of the Exports of Lebanon in 2012 to that in 2013?
Provide a succinct answer. 1.01. What is the ratio of the Exports of Macedonia in 2012 to that in 2013?
Give a very brief answer. 1.03. What is the ratio of the Exports in Albania in 2012 to that in 2014?
Offer a very short reply. 0.92. What is the ratio of the Exports in Cote d'Ivoire in 2012 to that in 2014?
Your answer should be compact. 0.91. What is the ratio of the Exports of Lebanon in 2012 to that in 2014?
Provide a short and direct response. 0.97. What is the ratio of the Exports of Macedonia in 2012 to that in 2014?
Your response must be concise. 0.88. What is the ratio of the Exports in Albania in 2013 to that in 2014?
Make the answer very short. 0.99. What is the ratio of the Exports in Cote d'Ivoire in 2013 to that in 2014?
Give a very brief answer. 0.96. What is the ratio of the Exports in Lebanon in 2013 to that in 2014?
Provide a succinct answer. 0.97. What is the ratio of the Exports of Macedonia in 2013 to that in 2014?
Your answer should be very brief. 0.85. What is the difference between the highest and the second highest Exports in Albania?
Your answer should be compact. 4.86e+09. What is the difference between the highest and the second highest Exports of Cote d'Ivoire?
Your response must be concise. 2.47e+11. What is the difference between the highest and the second highest Exports of Lebanon?
Your answer should be compact. 2.30e+11. What is the difference between the highest and the second highest Exports in Macedonia?
Provide a short and direct response. 2.29e+1. What is the difference between the highest and the lowest Exports in Albania?
Offer a very short reply. 1.03e+11. What is the difference between the highest and the lowest Exports in Cote d'Ivoire?
Give a very brief answer. 1.29e+12. What is the difference between the highest and the lowest Exports of Lebanon?
Your answer should be very brief. 2.53e+12. What is the difference between the highest and the lowest Exports of Macedonia?
Your response must be concise. 7.51e+1. 